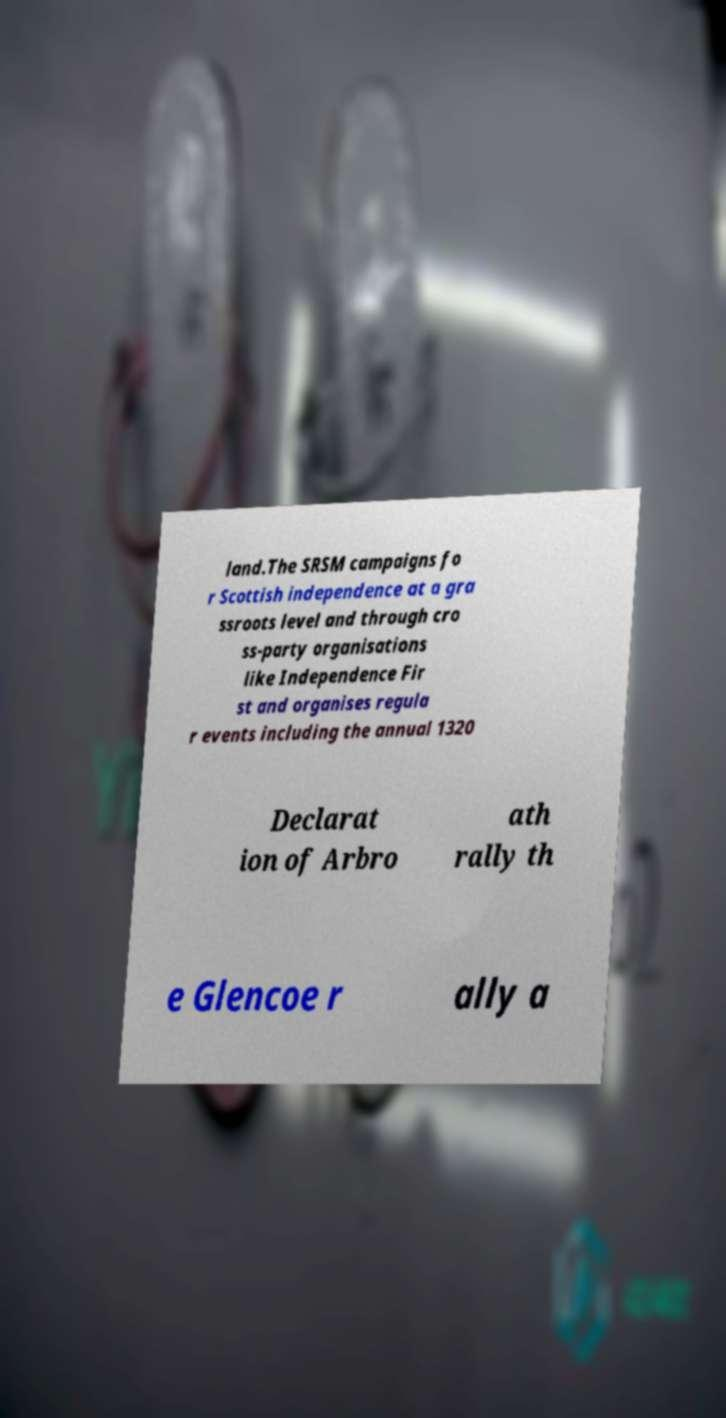Could you extract and type out the text from this image? land.The SRSM campaigns fo r Scottish independence at a gra ssroots level and through cro ss-party organisations like Independence Fir st and organises regula r events including the annual 1320 Declarat ion of Arbro ath rally th e Glencoe r ally a 